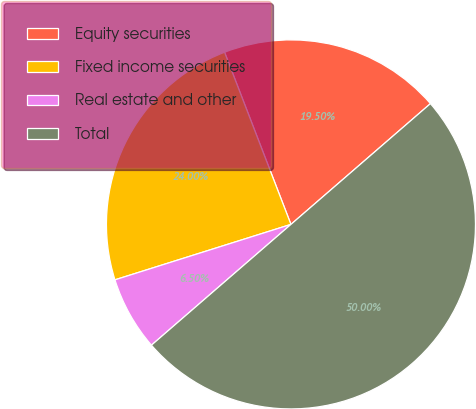<chart> <loc_0><loc_0><loc_500><loc_500><pie_chart><fcel>Equity securities<fcel>Fixed income securities<fcel>Real estate and other<fcel>Total<nl><fcel>19.5%<fcel>24.0%<fcel>6.5%<fcel>50.0%<nl></chart> 